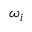<formula> <loc_0><loc_0><loc_500><loc_500>\omega _ { i }</formula> 